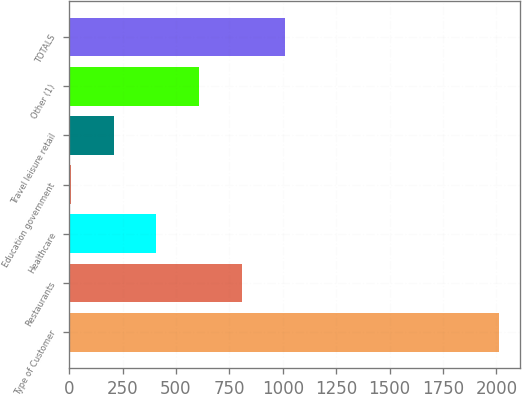Convert chart. <chart><loc_0><loc_0><loc_500><loc_500><bar_chart><fcel>Type of Customer<fcel>Restaurants<fcel>Healthcare<fcel>Education government<fcel>Travel leisure retail<fcel>Other (1)<fcel>TOTALS<nl><fcel>2012<fcel>809.6<fcel>408.8<fcel>8<fcel>208.4<fcel>609.2<fcel>1010<nl></chart> 